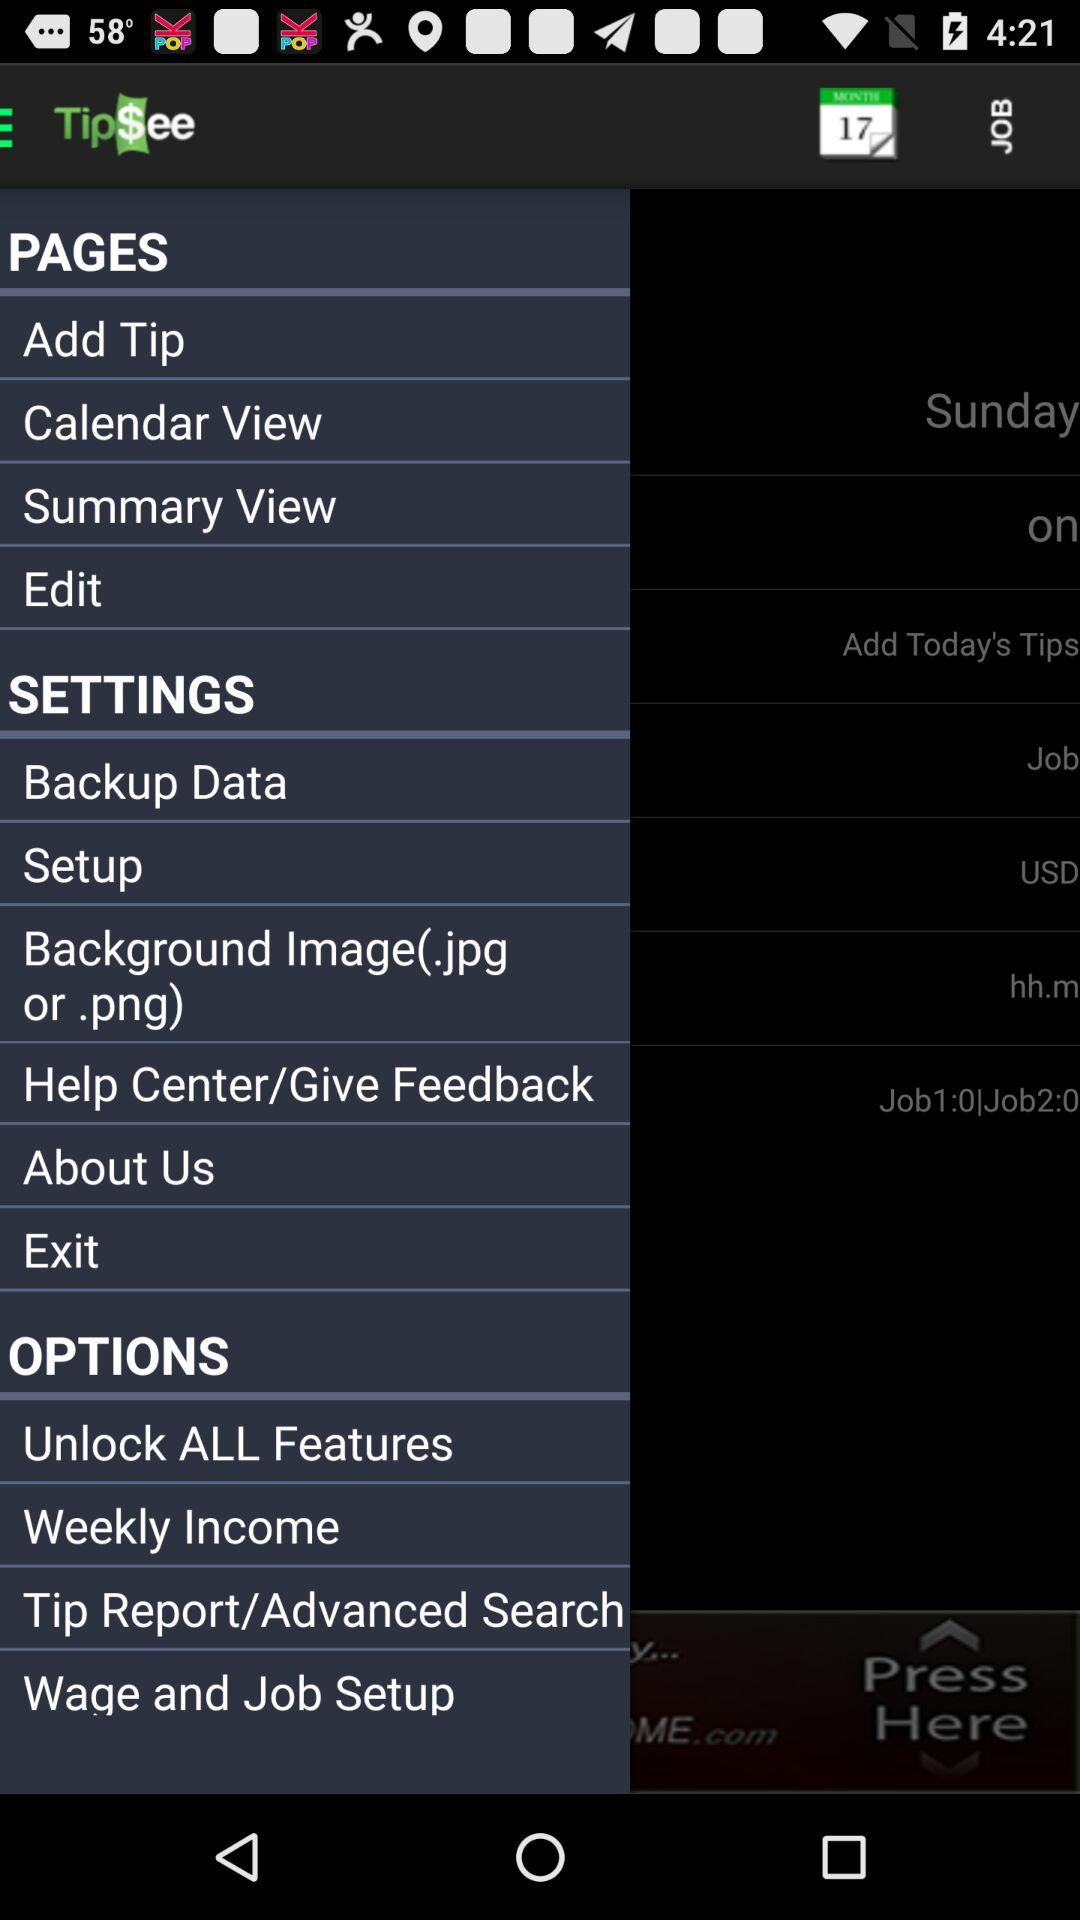What is the selected date? The selected date is Saturday, February 18, 2017. 